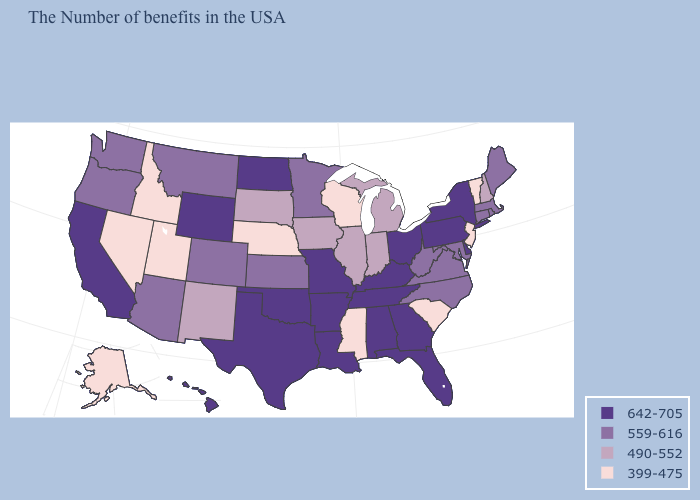Does Utah have the highest value in the USA?
Write a very short answer. No. Does Utah have the lowest value in the West?
Write a very short answer. Yes. What is the highest value in the MidWest ?
Concise answer only. 642-705. Does Tennessee have the highest value in the USA?
Give a very brief answer. Yes. Does the map have missing data?
Keep it brief. No. Does Massachusetts have a higher value than North Dakota?
Answer briefly. No. What is the lowest value in the USA?
Give a very brief answer. 399-475. What is the value of California?
Write a very short answer. 642-705. What is the value of Connecticut?
Short answer required. 559-616. Name the states that have a value in the range 559-616?
Concise answer only. Maine, Massachusetts, Rhode Island, Connecticut, Maryland, Virginia, North Carolina, West Virginia, Minnesota, Kansas, Colorado, Montana, Arizona, Washington, Oregon. Among the states that border Washington , does Idaho have the highest value?
Quick response, please. No. What is the value of Missouri?
Give a very brief answer. 642-705. What is the value of Kentucky?
Quick response, please. 642-705. What is the highest value in the USA?
Keep it brief. 642-705. Does the first symbol in the legend represent the smallest category?
Short answer required. No. 